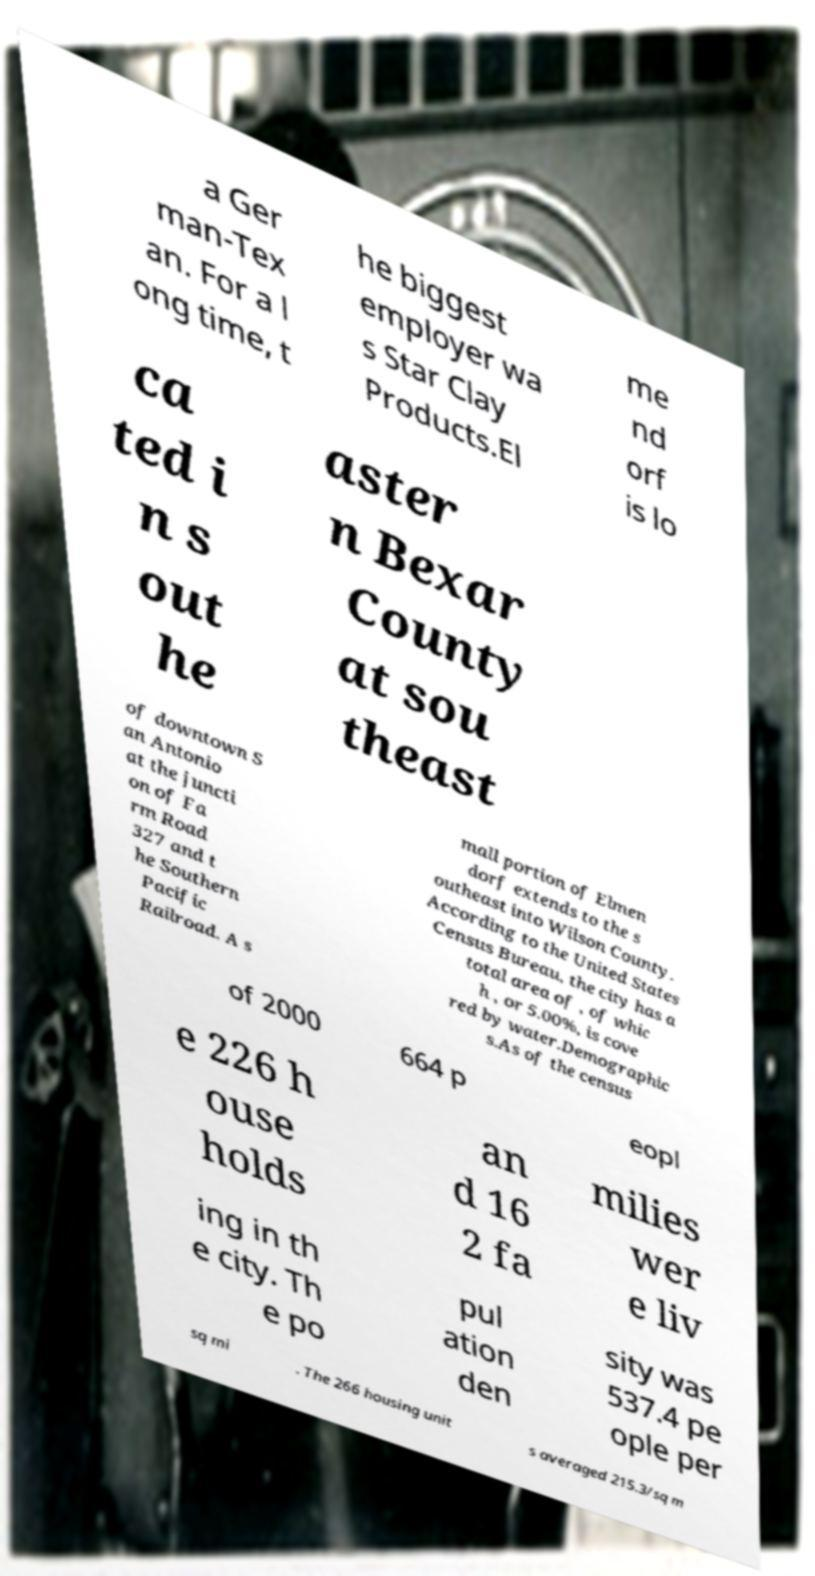There's text embedded in this image that I need extracted. Can you transcribe it verbatim? a Ger man-Tex an. For a l ong time, t he biggest employer wa s Star Clay Products.El me nd orf is lo ca ted i n s out he aster n Bexar County at sou theast of downtown S an Antonio at the juncti on of Fa rm Road 327 and t he Southern Pacific Railroad. A s mall portion of Elmen dorf extends to the s outheast into Wilson County. According to the United States Census Bureau, the city has a total area of , of whic h , or 5.00%, is cove red by water.Demographic s.As of the census of 2000 664 p eopl e 226 h ouse holds an d 16 2 fa milies wer e liv ing in th e city. Th e po pul ation den sity was 537.4 pe ople per sq mi . The 266 housing unit s averaged 215.3/sq m 